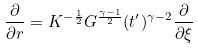Convert formula to latex. <formula><loc_0><loc_0><loc_500><loc_500>\frac { \partial } { \partial r } = K ^ { - \frac { 1 } { 2 } } G ^ { \frac { \gamma - 1 } { 2 } } ( t ^ { \prime } ) ^ { \gamma - 2 } \frac { \partial } { \partial \xi }</formula> 